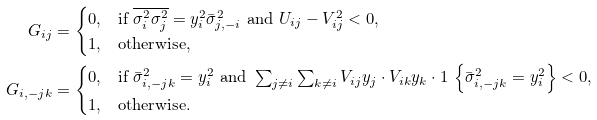Convert formula to latex. <formula><loc_0><loc_0><loc_500><loc_500>G _ { i j } & = \begin{cases} 0 , & \text {if } \overline { \sigma _ { i } ^ { 2 } \sigma _ { j } ^ { 2 } } = y _ { i } ^ { 2 } \bar { \sigma } _ { j , - i } ^ { 2 } \text { and } U _ { i j } - V _ { i j } ^ { 2 } < 0 , \\ 1 , & \text {otherwise} , \end{cases} \\ G _ { i , - j k } & = \begin{cases} 0 , & \text {if } \bar { \sigma } _ { i , - j k } ^ { 2 } = y _ { i } ^ { 2 } \text { and } \sum _ { j \neq i } \sum _ { k \neq i } V _ { i j } y _ { j } \cdot V _ { i k } y _ { k } \cdot 1 \, \left \{ \bar { \sigma } _ { i , - j k } ^ { 2 } = y _ { i } ^ { 2 } \right \} < 0 , \\ 1 , & \text {otherwise} . \end{cases}</formula> 